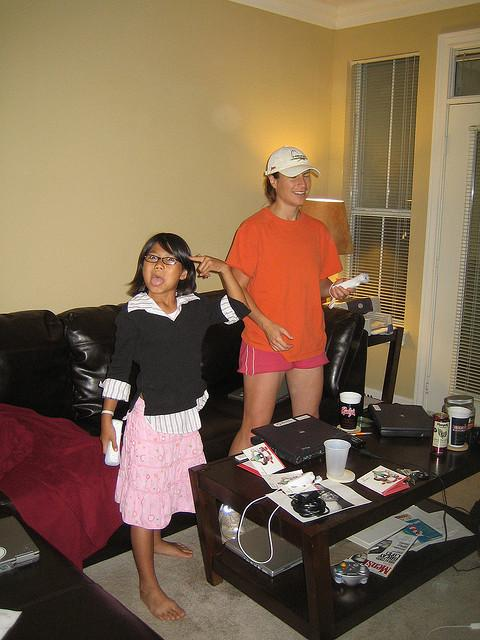What is the girl pointing to? Please explain your reasoning. head. Her index finger is rested against her noggin. 